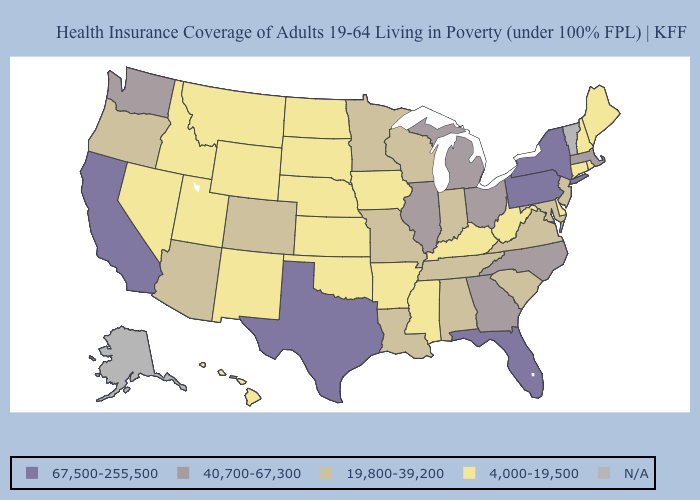What is the value of Tennessee?
Concise answer only. 19,800-39,200. Does Texas have the highest value in the USA?
Concise answer only. Yes. Which states have the lowest value in the West?
Quick response, please. Hawaii, Idaho, Montana, Nevada, New Mexico, Utah, Wyoming. What is the lowest value in states that border Nebraska?
Answer briefly. 4,000-19,500. What is the value of Maryland?
Concise answer only. 19,800-39,200. Which states have the lowest value in the South?
Concise answer only. Arkansas, Delaware, Kentucky, Mississippi, Oklahoma, West Virginia. Does the map have missing data?
Quick response, please. Yes. What is the value of Iowa?
Write a very short answer. 4,000-19,500. What is the lowest value in the USA?
Keep it brief. 4,000-19,500. Does New Mexico have the lowest value in the USA?
Give a very brief answer. Yes. Name the states that have a value in the range 67,500-255,500?
Answer briefly. California, Florida, New York, Pennsylvania, Texas. Name the states that have a value in the range N/A?
Quick response, please. Alaska, Vermont. Does the map have missing data?
Be succinct. Yes. Among the states that border Nevada , which have the highest value?
Give a very brief answer. California. Name the states that have a value in the range N/A?
Concise answer only. Alaska, Vermont. 